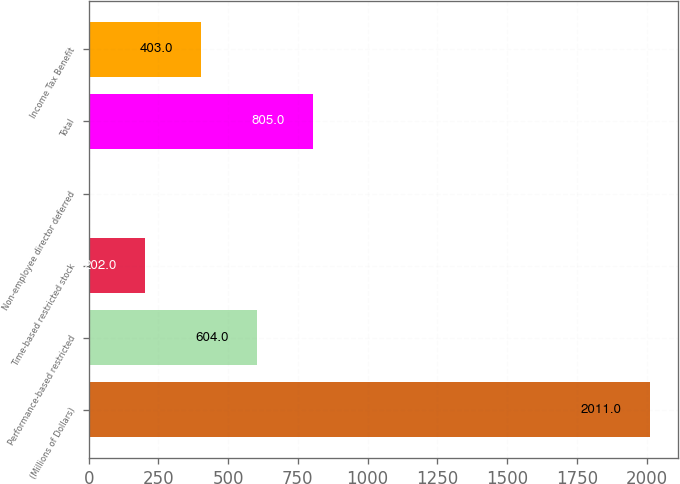Convert chart to OTSL. <chart><loc_0><loc_0><loc_500><loc_500><bar_chart><fcel>(Millions of Dollars)<fcel>Performance-based restricted<fcel>Time-based restricted stock<fcel>Non-employee director deferred<fcel>Total<fcel>Income Tax Benefit<nl><fcel>2011<fcel>604<fcel>202<fcel>1<fcel>805<fcel>403<nl></chart> 